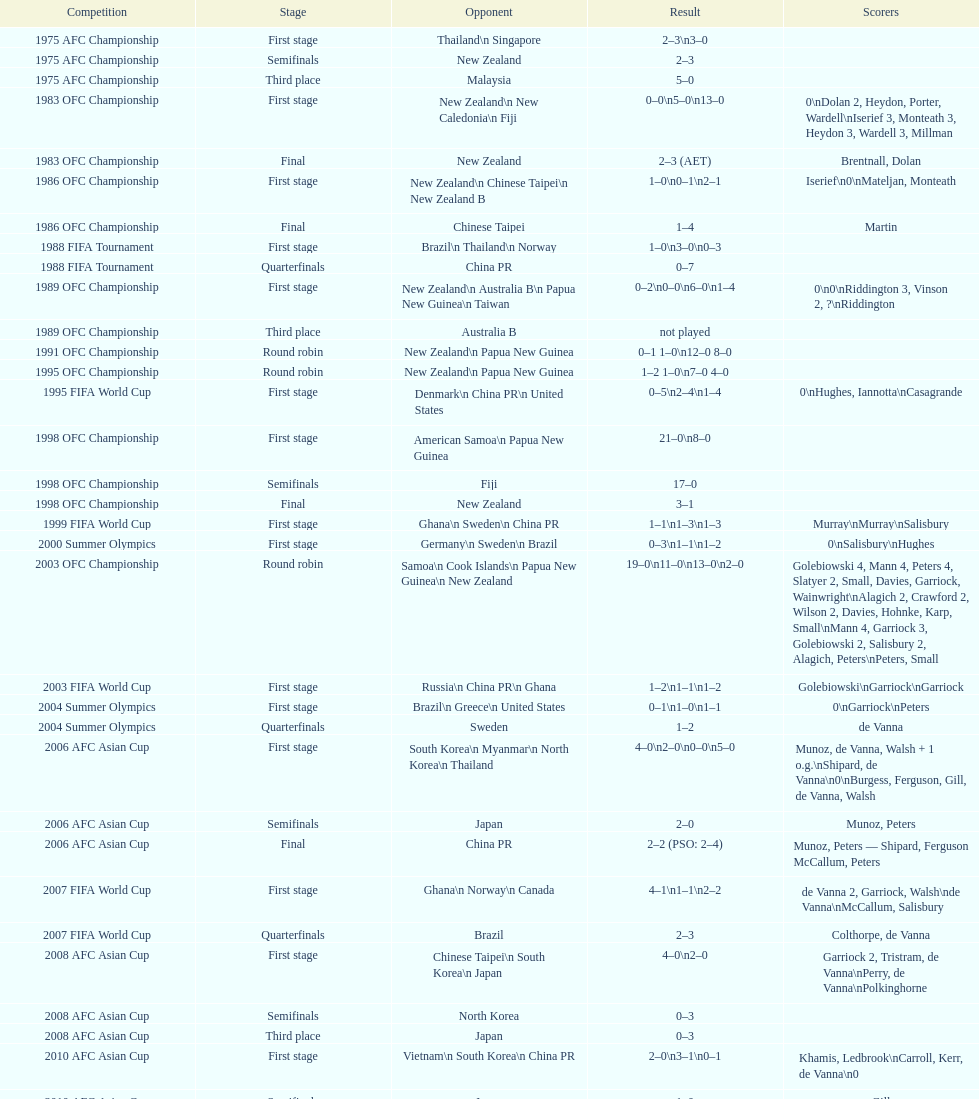How many goals were scored altogether in the 1983 ofc championship? 18. Help me parse the entirety of this table. {'header': ['Competition', 'Stage', 'Opponent', 'Result', 'Scorers'], 'rows': [['1975 AFC Championship', 'First stage', 'Thailand\\n\xa0Singapore', '2–3\\n3–0', ''], ['1975 AFC Championship', 'Semifinals', 'New Zealand', '2–3', ''], ['1975 AFC Championship', 'Third place', 'Malaysia', '5–0', ''], ['1983 OFC Championship', 'First stage', 'New Zealand\\n\xa0New Caledonia\\n\xa0Fiji', '0–0\\n5–0\\n13–0', '0\\nDolan 2, Heydon, Porter, Wardell\\nIserief 3, Monteath 3, Heydon 3, Wardell 3, Millman'], ['1983 OFC Championship', 'Final', 'New Zealand', '2–3 (AET)', 'Brentnall, Dolan'], ['1986 OFC Championship', 'First stage', 'New Zealand\\n\xa0Chinese Taipei\\n New Zealand B', '1–0\\n0–1\\n2–1', 'Iserief\\n0\\nMateljan, Monteath'], ['1986 OFC Championship', 'Final', 'Chinese Taipei', '1–4', 'Martin'], ['1988 FIFA Tournament', 'First stage', 'Brazil\\n\xa0Thailand\\n\xa0Norway', '1–0\\n3–0\\n0–3', ''], ['1988 FIFA Tournament', 'Quarterfinals', 'China PR', '0–7', ''], ['1989 OFC Championship', 'First stage', 'New Zealand\\n Australia B\\n\xa0Papua New Guinea\\n\xa0Taiwan', '0–2\\n0–0\\n6–0\\n1–4', '0\\n0\\nRiddington 3, Vinson 2,\xa0?\\nRiddington'], ['1989 OFC Championship', 'Third place', 'Australia B', 'not played', ''], ['1991 OFC Championship', 'Round robin', 'New Zealand\\n\xa0Papua New Guinea', '0–1 1–0\\n12–0 8–0', ''], ['1995 OFC Championship', 'Round robin', 'New Zealand\\n\xa0Papua New Guinea', '1–2 1–0\\n7–0 4–0', ''], ['1995 FIFA World Cup', 'First stage', 'Denmark\\n\xa0China PR\\n\xa0United States', '0–5\\n2–4\\n1–4', '0\\nHughes, Iannotta\\nCasagrande'], ['1998 OFC Championship', 'First stage', 'American Samoa\\n\xa0Papua New Guinea', '21–0\\n8–0', ''], ['1998 OFC Championship', 'Semifinals', 'Fiji', '17–0', ''], ['1998 OFC Championship', 'Final', 'New Zealand', '3–1', ''], ['1999 FIFA World Cup', 'First stage', 'Ghana\\n\xa0Sweden\\n\xa0China PR', '1–1\\n1–3\\n1–3', 'Murray\\nMurray\\nSalisbury'], ['2000 Summer Olympics', 'First stage', 'Germany\\n\xa0Sweden\\n\xa0Brazil', '0–3\\n1–1\\n1–2', '0\\nSalisbury\\nHughes'], ['2003 OFC Championship', 'Round robin', 'Samoa\\n\xa0Cook Islands\\n\xa0Papua New Guinea\\n\xa0New Zealand', '19–0\\n11–0\\n13–0\\n2–0', 'Golebiowski 4, Mann 4, Peters 4, Slatyer 2, Small, Davies, Garriock, Wainwright\\nAlagich 2, Crawford 2, Wilson 2, Davies, Hohnke, Karp, Small\\nMann 4, Garriock 3, Golebiowski 2, Salisbury 2, Alagich, Peters\\nPeters, Small'], ['2003 FIFA World Cup', 'First stage', 'Russia\\n\xa0China PR\\n\xa0Ghana', '1–2\\n1–1\\n1–2', 'Golebiowski\\nGarriock\\nGarriock'], ['2004 Summer Olympics', 'First stage', 'Brazil\\n\xa0Greece\\n\xa0United States', '0–1\\n1–0\\n1–1', '0\\nGarriock\\nPeters'], ['2004 Summer Olympics', 'Quarterfinals', 'Sweden', '1–2', 'de Vanna'], ['2006 AFC Asian Cup', 'First stage', 'South Korea\\n\xa0Myanmar\\n\xa0North Korea\\n\xa0Thailand', '4–0\\n2–0\\n0–0\\n5–0', 'Munoz, de Vanna, Walsh + 1 o.g.\\nShipard, de Vanna\\n0\\nBurgess, Ferguson, Gill, de Vanna, Walsh'], ['2006 AFC Asian Cup', 'Semifinals', 'Japan', '2–0', 'Munoz, Peters'], ['2006 AFC Asian Cup', 'Final', 'China PR', '2–2 (PSO: 2–4)', 'Munoz, Peters — Shipard, Ferguson McCallum, Peters'], ['2007 FIFA World Cup', 'First stage', 'Ghana\\n\xa0Norway\\n\xa0Canada', '4–1\\n1–1\\n2–2', 'de Vanna 2, Garriock, Walsh\\nde Vanna\\nMcCallum, Salisbury'], ['2007 FIFA World Cup', 'Quarterfinals', 'Brazil', '2–3', 'Colthorpe, de Vanna'], ['2008 AFC Asian Cup', 'First stage', 'Chinese Taipei\\n\xa0South Korea\\n\xa0Japan', '4–0\\n2–0', 'Garriock 2, Tristram, de Vanna\\nPerry, de Vanna\\nPolkinghorne'], ['2008 AFC Asian Cup', 'Semifinals', 'North Korea', '0–3', ''], ['2008 AFC Asian Cup', 'Third place', 'Japan', '0–3', ''], ['2010 AFC Asian Cup', 'First stage', 'Vietnam\\n\xa0South Korea\\n\xa0China PR', '2–0\\n3–1\\n0–1', 'Khamis, Ledbrook\\nCarroll, Kerr, de Vanna\\n0'], ['2010 AFC Asian Cup', 'Semifinals', 'Japan', '1–0', 'Gill'], ['2010 AFC Asian Cup', 'Final', 'North Korea', '1–1 (PSO: 5–4)', 'Kerr — PSO: Shipard, Ledbrook, Gill, Garriock, Simon'], ['2011 FIFA World Cup', 'First stage', 'Brazil\\n\xa0Equatorial Guinea\\n\xa0Norway', '0–1\\n3–2\\n2–1', '0\\nvan Egmond, Khamis, de Vanna\\nSimon 2'], ['2011 FIFA World Cup', 'Quarterfinals', 'Sweden', '1–3', 'Perry'], ['2012 Summer Olympics\\nAFC qualification', 'Final round', 'North Korea\\n\xa0Thailand\\n\xa0Japan\\n\xa0China PR\\n\xa0South Korea', '0–1\\n5–1\\n0–1\\n1–0\\n2–1', '0\\nHeyman 2, Butt, van Egmond, Simon\\n0\\nvan Egmond\\nButt, de Vanna'], ['2014 AFC Asian Cup', 'First stage', 'Japan\\n\xa0Jordan\\n\xa0Vietnam', 'TBD\\nTBD\\nTBD', '']]} 